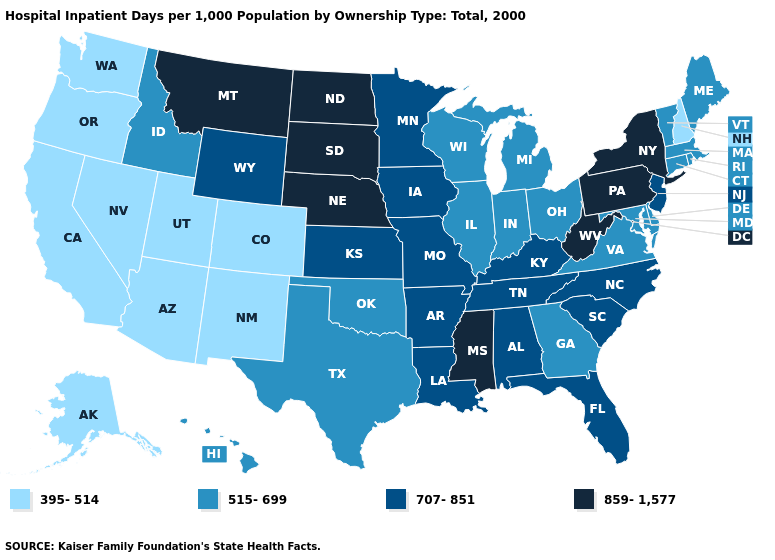Name the states that have a value in the range 707-851?
Be succinct. Alabama, Arkansas, Florida, Iowa, Kansas, Kentucky, Louisiana, Minnesota, Missouri, New Jersey, North Carolina, South Carolina, Tennessee, Wyoming. Does the map have missing data?
Concise answer only. No. Among the states that border Nebraska , does Colorado have the lowest value?
Give a very brief answer. Yes. Does Montana have the highest value in the West?
Be succinct. Yes. What is the value of Nebraska?
Short answer required. 859-1,577. What is the value of Colorado?
Keep it brief. 395-514. What is the value of Kansas?
Write a very short answer. 707-851. Name the states that have a value in the range 859-1,577?
Write a very short answer. Mississippi, Montana, Nebraska, New York, North Dakota, Pennsylvania, South Dakota, West Virginia. Name the states that have a value in the range 859-1,577?
Quick response, please. Mississippi, Montana, Nebraska, New York, North Dakota, Pennsylvania, South Dakota, West Virginia. What is the value of Arizona?
Concise answer only. 395-514. What is the value of North Dakota?
Write a very short answer. 859-1,577. Does the map have missing data?
Quick response, please. No. What is the value of North Dakota?
Short answer required. 859-1,577. Name the states that have a value in the range 859-1,577?
Be succinct. Mississippi, Montana, Nebraska, New York, North Dakota, Pennsylvania, South Dakota, West Virginia. What is the value of Pennsylvania?
Give a very brief answer. 859-1,577. 